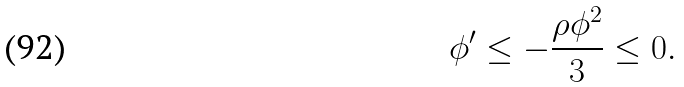<formula> <loc_0><loc_0><loc_500><loc_500>\phi ^ { \prime } \leq - \frac { \rho \phi ^ { 2 } } { 3 } \leq 0 .</formula> 